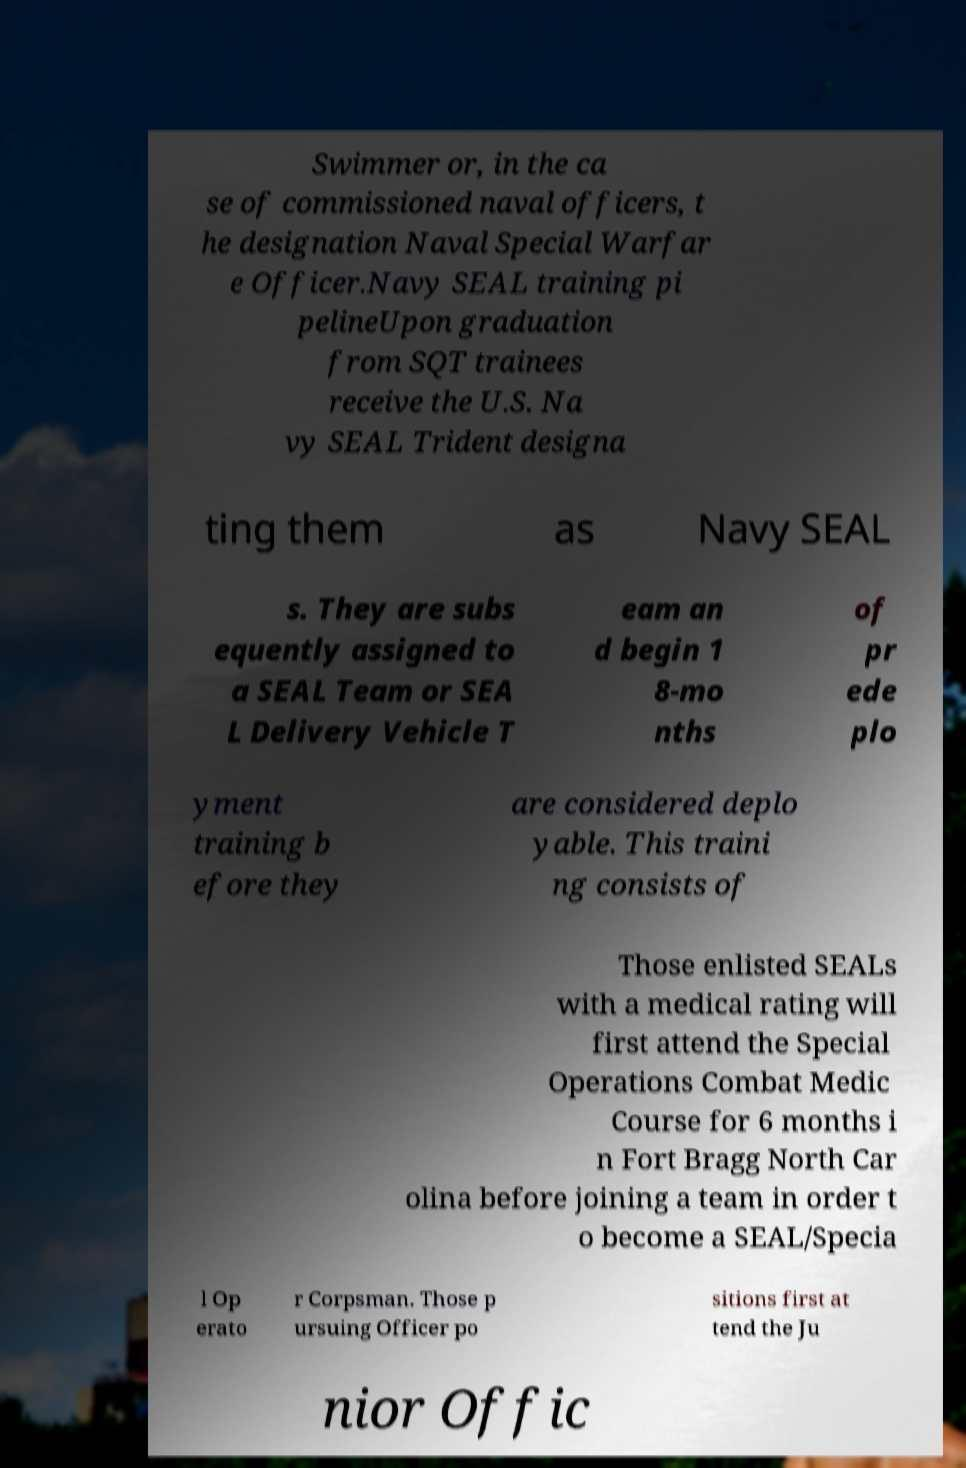Please identify and transcribe the text found in this image. Swimmer or, in the ca se of commissioned naval officers, t he designation Naval Special Warfar e Officer.Navy SEAL training pi pelineUpon graduation from SQT trainees receive the U.S. Na vy SEAL Trident designa ting them as Navy SEAL s. They are subs equently assigned to a SEAL Team or SEA L Delivery Vehicle T eam an d begin 1 8-mo nths of pr ede plo yment training b efore they are considered deplo yable. This traini ng consists of Those enlisted SEALs with a medical rating will first attend the Special Operations Combat Medic Course for 6 months i n Fort Bragg North Car olina before joining a team in order t o become a SEAL/Specia l Op erato r Corpsman. Those p ursuing Officer po sitions first at tend the Ju nior Offic 